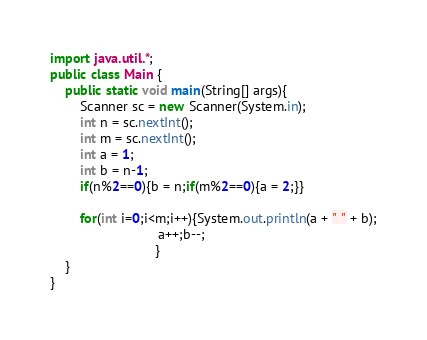<code> <loc_0><loc_0><loc_500><loc_500><_Java_>import java.util.*;
public class Main {
	public static void main(String[] args){
		Scanner sc = new Scanner(System.in);
		int n = sc.nextInt();		
        int m = sc.nextInt();
		int a = 1;
        int b = n-1;
        if(n%2==0){b = n;if(m%2==0){a = 2;}}
        
        for(int i=0;i<m;i++){System.out.println(a + " " + b);
                             a++;b--;
                            }                         		
	}
}</code> 